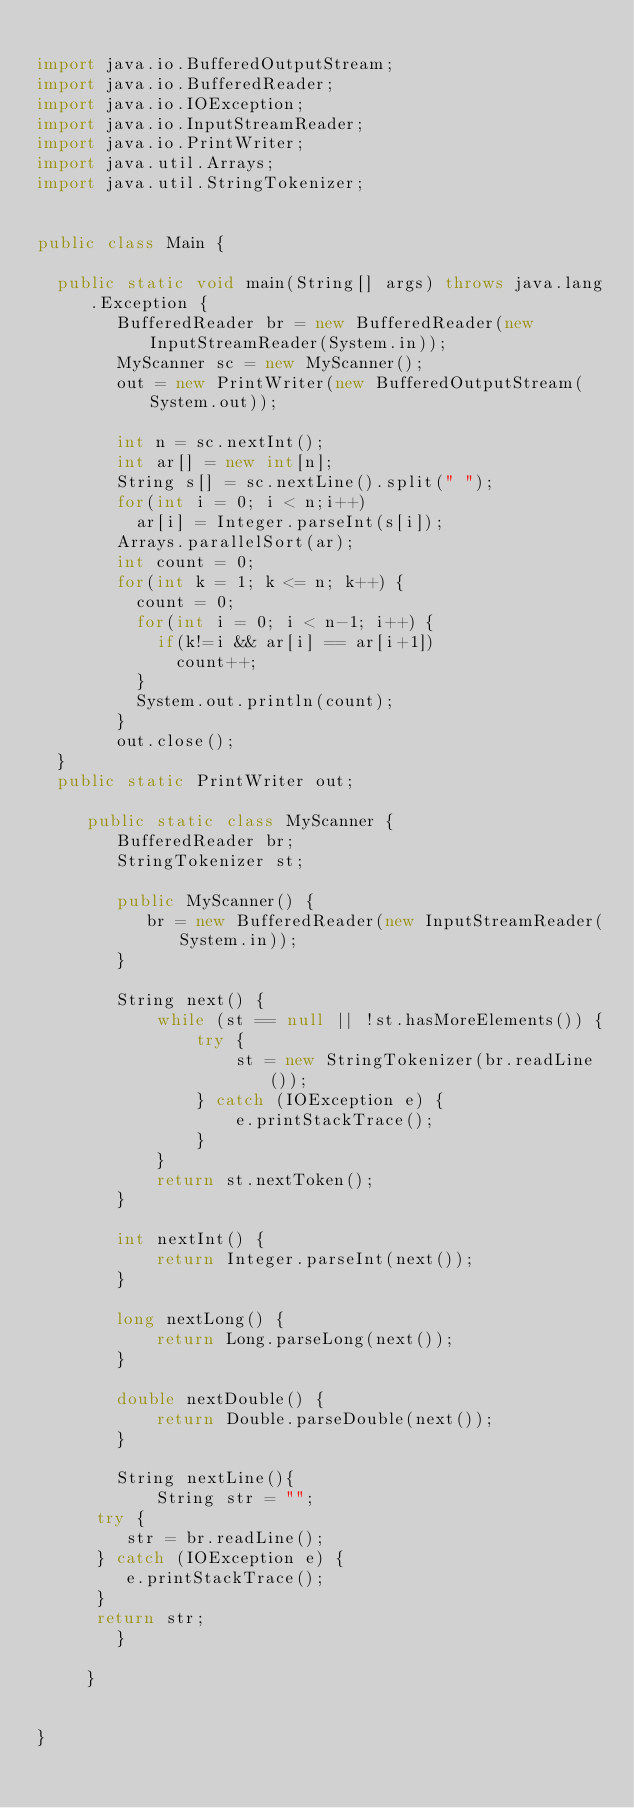Convert code to text. <code><loc_0><loc_0><loc_500><loc_500><_Java_>
import java.io.BufferedOutputStream;
import java.io.BufferedReader;
import java.io.IOException;
import java.io.InputStreamReader;
import java.io.PrintWriter;
import java.util.Arrays;
import java.util.StringTokenizer;


public class Main {
	
	public static void main(String[] args) throws java.lang.Exception {
	      BufferedReader br = new BufferedReader(new InputStreamReader(System.in));
	      MyScanner sc = new MyScanner();
	      out = new PrintWriter(new BufferedOutputStream(System.out));
	      
	      int n = sc.nextInt();
	      int ar[] = new int[n];
	      String s[] = sc.nextLine().split(" ");
	      for(int i = 0; i < n;i++)
	    	  ar[i] = Integer.parseInt(s[i]);
	      Arrays.parallelSort(ar);
	      int count = 0;
	      for(int k = 1; k <= n; k++) {
	    	  count = 0;
	    	  for(int i = 0; i < n-1; i++) {
	    		  if(k!=i && ar[i] == ar[i+1])
	    			  count++;
	    	  }
	    	  System.out.println(count);
	      }
	      out.close();
	}
	public static PrintWriter out;

	   public static class MyScanner {
	      BufferedReader br;
	      StringTokenizer st;
	 
	      public MyScanner() {
	         br = new BufferedReader(new InputStreamReader(System.in));
	      }
	 
	      String next() {
	          while (st == null || !st.hasMoreElements()) {
	              try {
	                  st = new StringTokenizer(br.readLine());
	              } catch (IOException e) {
	                  e.printStackTrace();
	              }
	          }
	          return st.nextToken();
	      }
	 
	      int nextInt() {
	          return Integer.parseInt(next());
	      }
	 
	      long nextLong() {
	          return Long.parseLong(next());
	      }
	 
	      double nextDouble() {
	          return Double.parseDouble(next());
	      }
	 
	      String nextLine(){
	          String str = "";
		  try {
		     str = br.readLine();
		  } catch (IOException e) {
		     e.printStackTrace();
		  }
		  return str;
	      }

	   }


}
</code> 